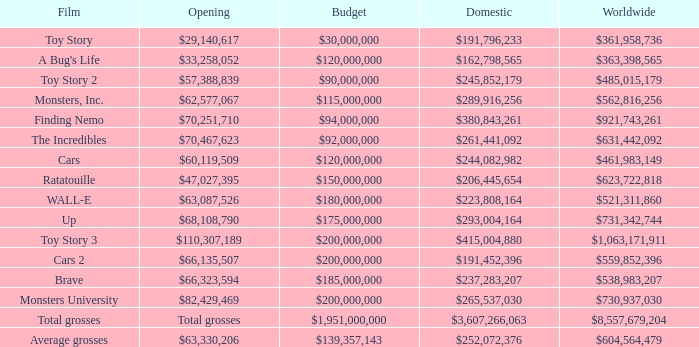WHAT IS THE WORLDWIDE BOX OFFICE FOR BRAVE? $538,983,207. 